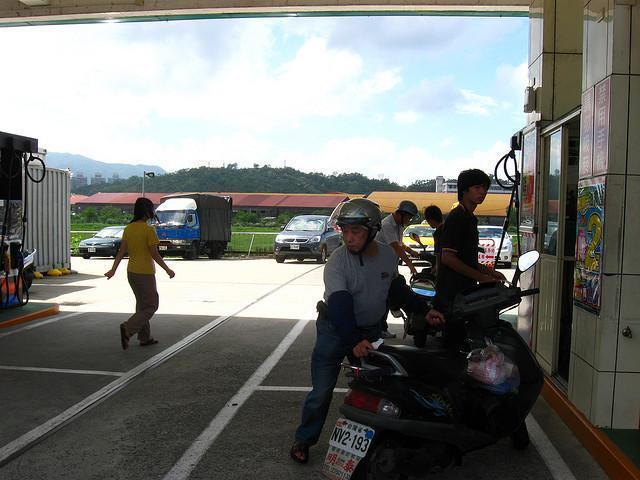How many people are in the picture?
Give a very brief answer. 3. How many giraffes are standing?
Give a very brief answer. 0. 